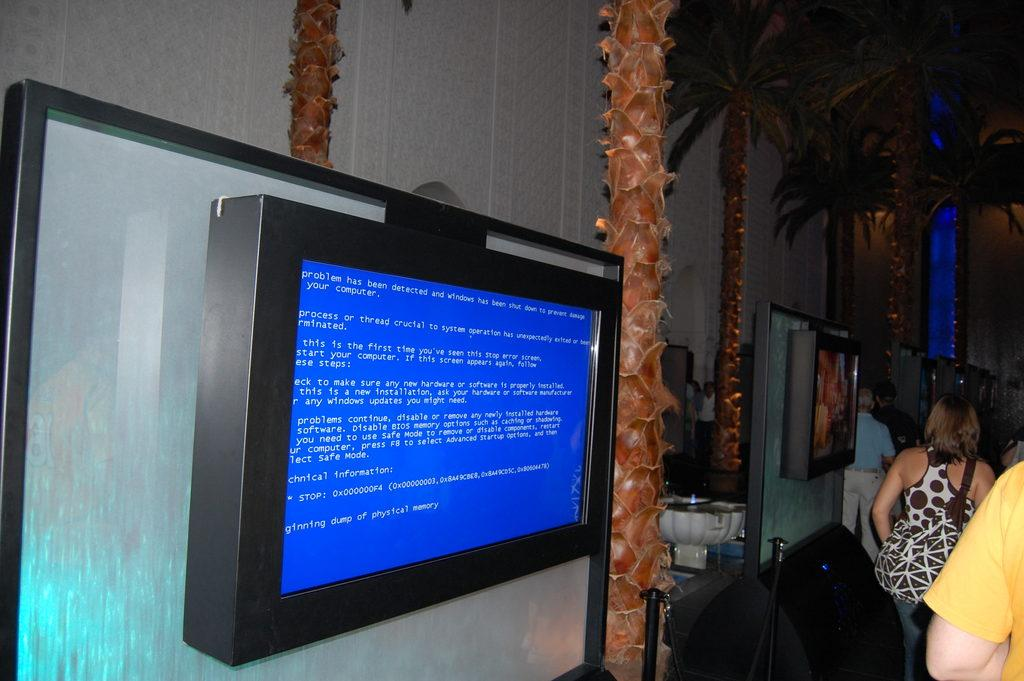Who or what can be seen in the image? There are people in the image. What type of natural elements are present in the image? There are trees in the image. What objects are attached to a board in the image? There are screens attached to a board in the image. What type of structure is visible in the image? There is a wall visible in the image. What type of vertical structures can be seen in the image? There are poles in the image. How much money is being exchanged between the people in the image? There is no indication of money or any exchange of money in the image. 